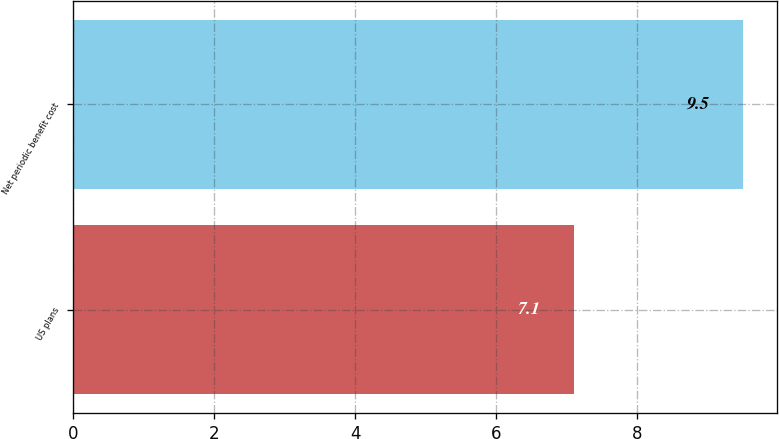<chart> <loc_0><loc_0><loc_500><loc_500><bar_chart><fcel>US plans<fcel>Net periodic benefit cost<nl><fcel>7.1<fcel>9.5<nl></chart> 